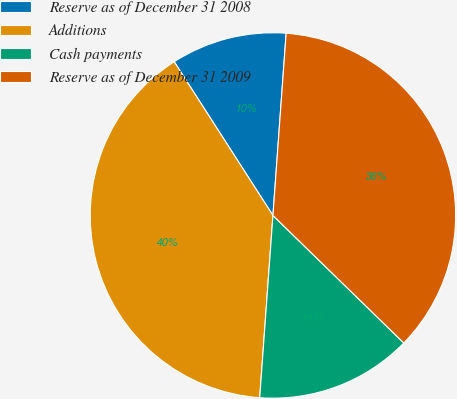<chart> <loc_0><loc_0><loc_500><loc_500><pie_chart><fcel>Reserve as of December 31 2008<fcel>Additions<fcel>Cash payments<fcel>Reserve as of December 31 2009<nl><fcel>10.24%<fcel>39.76%<fcel>13.86%<fcel>36.14%<nl></chart> 